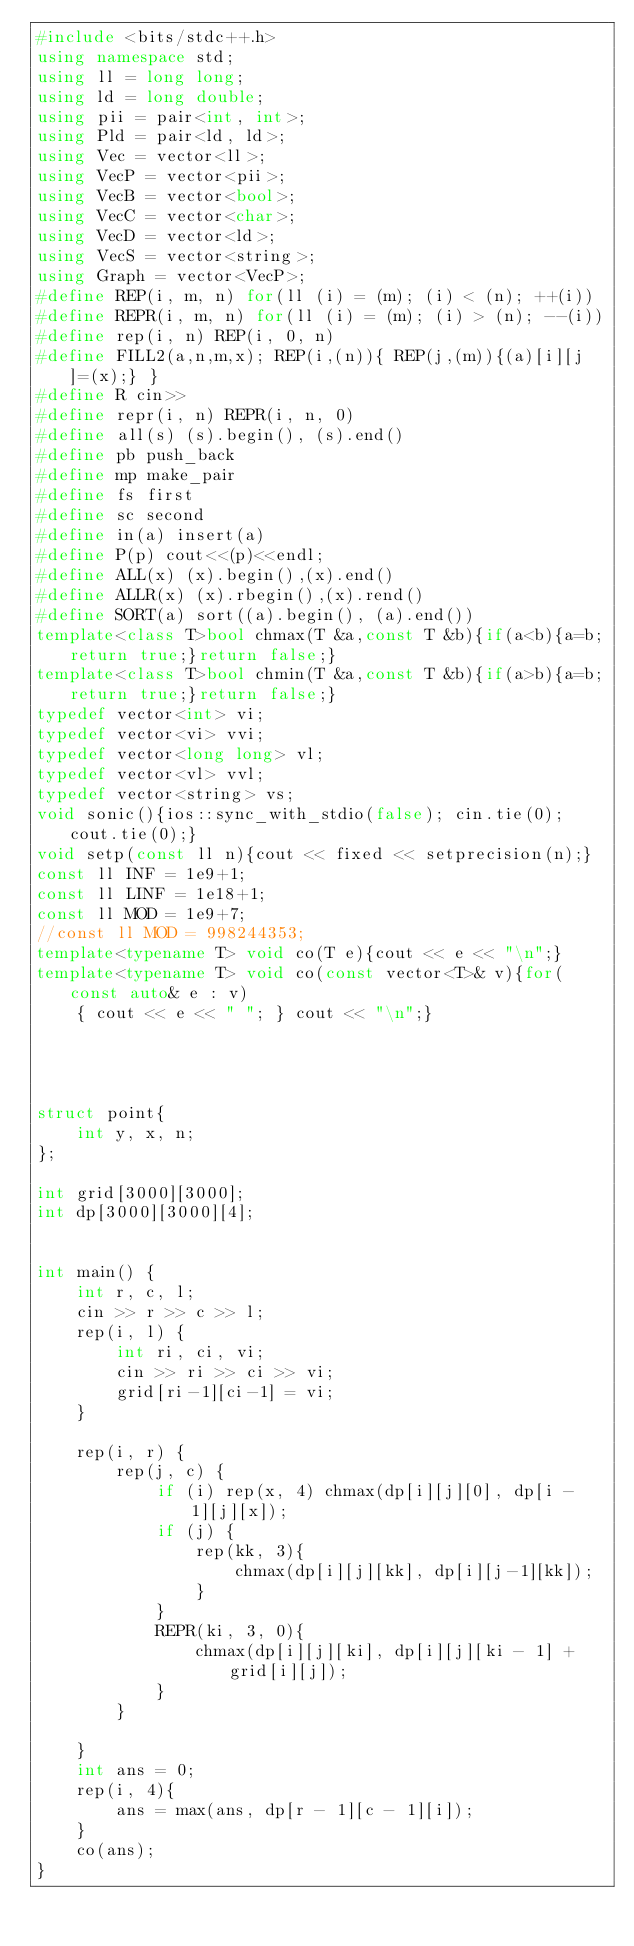Convert code to text. <code><loc_0><loc_0><loc_500><loc_500><_C++_>#include <bits/stdc++.h>
using namespace std;
using ll = long long;
using ld = long double;
using pii = pair<int, int>;
using Pld = pair<ld, ld>;
using Vec = vector<ll>;
using VecP = vector<pii>;
using VecB = vector<bool>;
using VecC = vector<char>;
using VecD = vector<ld>;
using VecS = vector<string>;
using Graph = vector<VecP>;
#define REP(i, m, n) for(ll (i) = (m); (i) < (n); ++(i))
#define REPR(i, m, n) for(ll (i) = (m); (i) > (n); --(i))
#define rep(i, n) REP(i, 0, n)
#define FILL2(a,n,m,x); REP(i,(n)){ REP(j,(m)){(a)[i][j]=(x);} }
#define R cin>>
#define repr(i, n) REPR(i, n, 0)
#define all(s) (s).begin(), (s).end()
#define pb push_back
#define mp make_pair
#define fs first
#define sc second
#define in(a) insert(a)
#define P(p) cout<<(p)<<endl;
#define ALL(x) (x).begin(),(x).end()
#define ALLR(x) (x).rbegin(),(x).rend()
#define SORT(a) sort((a).begin(), (a).end())
template<class T>bool chmax(T &a,const T &b){if(a<b){a=b;return true;}return false;}
template<class T>bool chmin(T &a,const T &b){if(a>b){a=b;return true;}return false;}
typedef vector<int> vi;
typedef vector<vi> vvi;
typedef vector<long long> vl;
typedef vector<vl> vvl;
typedef vector<string> vs;
void sonic(){ios::sync_with_stdio(false); cin.tie(0); cout.tie(0);}
void setp(const ll n){cout << fixed << setprecision(n);}
const ll INF = 1e9+1;
const ll LINF = 1e18+1;
const ll MOD = 1e9+7;
//const ll MOD = 998244353;
template<typename T> void co(T e){cout << e << "\n";}
template<typename T> void co(const vector<T>& v){for(const auto& e : v)
    { cout << e << " "; } cout << "\n";}




struct point{
    int y, x, n;
};

int grid[3000][3000];
int dp[3000][3000][4];


int main() {
    int r, c, l;
    cin >> r >> c >> l;
    rep(i, l) {
        int ri, ci, vi;
        cin >> ri >> ci >> vi;
        grid[ri-1][ci-1] = vi;
    }

    rep(i, r) {
        rep(j, c) {
            if (i) rep(x, 4) chmax(dp[i][j][0], dp[i - 1][j][x]);
            if (j) {
                rep(kk, 3){
                    chmax(dp[i][j][kk], dp[i][j-1][kk]);
                }
            }
            REPR(ki, 3, 0){
                chmax(dp[i][j][ki], dp[i][j][ki - 1] + grid[i][j]);
            }
        }

    }
    int ans = 0;
    rep(i, 4){
        ans = max(ans, dp[r - 1][c - 1][i]);
    }
    co(ans);
}
</code> 